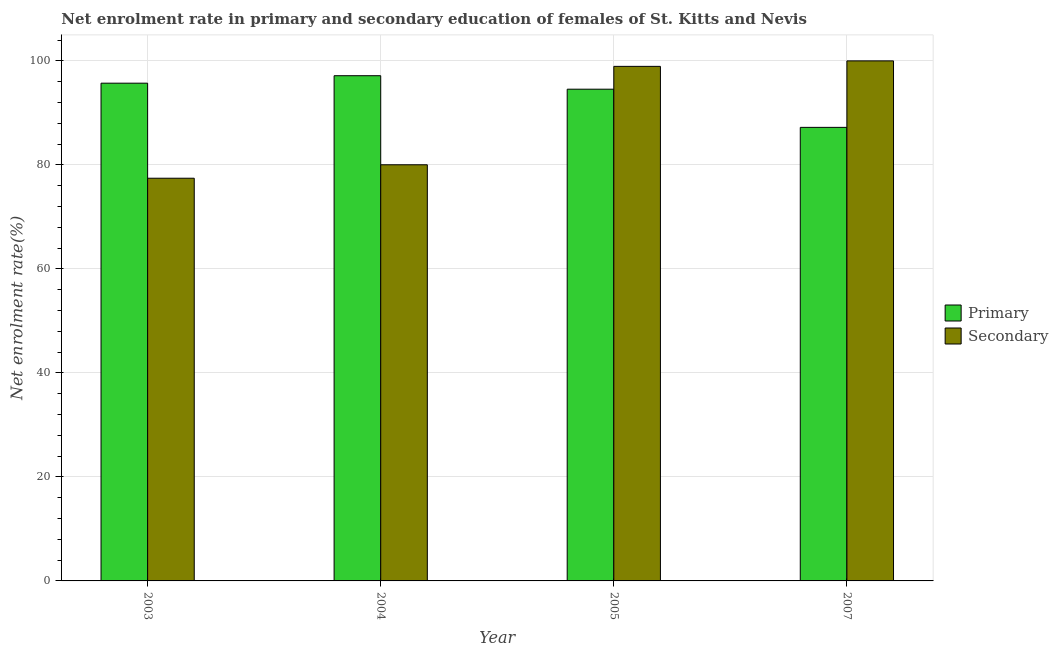How many different coloured bars are there?
Your response must be concise. 2. Are the number of bars per tick equal to the number of legend labels?
Offer a very short reply. Yes. Are the number of bars on each tick of the X-axis equal?
Provide a succinct answer. Yes. What is the enrollment rate in primary education in 2003?
Ensure brevity in your answer.  95.71. Across all years, what is the maximum enrollment rate in primary education?
Offer a very short reply. 97.15. Across all years, what is the minimum enrollment rate in primary education?
Provide a succinct answer. 87.21. What is the total enrollment rate in primary education in the graph?
Your response must be concise. 374.63. What is the difference between the enrollment rate in secondary education in 2004 and that in 2007?
Provide a short and direct response. -19.98. What is the difference between the enrollment rate in primary education in 2005 and the enrollment rate in secondary education in 2007?
Ensure brevity in your answer.  7.34. What is the average enrollment rate in primary education per year?
Provide a succinct answer. 93.66. In the year 2003, what is the difference between the enrollment rate in secondary education and enrollment rate in primary education?
Make the answer very short. 0. In how many years, is the enrollment rate in primary education greater than 8 %?
Provide a succinct answer. 4. What is the ratio of the enrollment rate in primary education in 2004 to that in 2007?
Make the answer very short. 1.11. What is the difference between the highest and the second highest enrollment rate in secondary education?
Make the answer very short. 1.06. What is the difference between the highest and the lowest enrollment rate in secondary education?
Make the answer very short. 22.57. In how many years, is the enrollment rate in secondary education greater than the average enrollment rate in secondary education taken over all years?
Make the answer very short. 2. What does the 2nd bar from the left in 2005 represents?
Your answer should be very brief. Secondary. What does the 1st bar from the right in 2007 represents?
Keep it short and to the point. Secondary. How many bars are there?
Your response must be concise. 8. Are all the bars in the graph horizontal?
Offer a very short reply. No. How many years are there in the graph?
Ensure brevity in your answer.  4. What is the difference between two consecutive major ticks on the Y-axis?
Ensure brevity in your answer.  20. Does the graph contain any zero values?
Your answer should be very brief. No. Does the graph contain grids?
Ensure brevity in your answer.  Yes. Where does the legend appear in the graph?
Provide a succinct answer. Center right. How many legend labels are there?
Your response must be concise. 2. How are the legend labels stacked?
Keep it short and to the point. Vertical. What is the title of the graph?
Your response must be concise. Net enrolment rate in primary and secondary education of females of St. Kitts and Nevis. What is the label or title of the Y-axis?
Your response must be concise. Net enrolment rate(%). What is the Net enrolment rate(%) of Primary in 2003?
Offer a terse response. 95.71. What is the Net enrolment rate(%) in Secondary in 2003?
Keep it short and to the point. 77.43. What is the Net enrolment rate(%) in Primary in 2004?
Ensure brevity in your answer.  97.15. What is the Net enrolment rate(%) of Secondary in 2004?
Give a very brief answer. 80.02. What is the Net enrolment rate(%) of Primary in 2005?
Provide a short and direct response. 94.55. What is the Net enrolment rate(%) of Secondary in 2005?
Give a very brief answer. 98.94. What is the Net enrolment rate(%) of Primary in 2007?
Offer a very short reply. 87.21. What is the Net enrolment rate(%) of Secondary in 2007?
Offer a very short reply. 100. Across all years, what is the maximum Net enrolment rate(%) in Primary?
Offer a very short reply. 97.15. Across all years, what is the maximum Net enrolment rate(%) of Secondary?
Provide a short and direct response. 100. Across all years, what is the minimum Net enrolment rate(%) of Primary?
Offer a very short reply. 87.21. Across all years, what is the minimum Net enrolment rate(%) of Secondary?
Your response must be concise. 77.43. What is the total Net enrolment rate(%) of Primary in the graph?
Ensure brevity in your answer.  374.63. What is the total Net enrolment rate(%) of Secondary in the graph?
Keep it short and to the point. 356.4. What is the difference between the Net enrolment rate(%) of Primary in 2003 and that in 2004?
Provide a short and direct response. -1.44. What is the difference between the Net enrolment rate(%) in Secondary in 2003 and that in 2004?
Provide a short and direct response. -2.59. What is the difference between the Net enrolment rate(%) of Primary in 2003 and that in 2005?
Your response must be concise. 1.16. What is the difference between the Net enrolment rate(%) in Secondary in 2003 and that in 2005?
Your response must be concise. -21.51. What is the difference between the Net enrolment rate(%) of Primary in 2003 and that in 2007?
Keep it short and to the point. 8.5. What is the difference between the Net enrolment rate(%) in Secondary in 2003 and that in 2007?
Provide a short and direct response. -22.57. What is the difference between the Net enrolment rate(%) in Primary in 2004 and that in 2005?
Ensure brevity in your answer.  2.59. What is the difference between the Net enrolment rate(%) of Secondary in 2004 and that in 2005?
Give a very brief answer. -18.92. What is the difference between the Net enrolment rate(%) in Primary in 2004 and that in 2007?
Your answer should be very brief. 9.93. What is the difference between the Net enrolment rate(%) in Secondary in 2004 and that in 2007?
Give a very brief answer. -19.98. What is the difference between the Net enrolment rate(%) in Primary in 2005 and that in 2007?
Give a very brief answer. 7.34. What is the difference between the Net enrolment rate(%) of Secondary in 2005 and that in 2007?
Offer a very short reply. -1.06. What is the difference between the Net enrolment rate(%) of Primary in 2003 and the Net enrolment rate(%) of Secondary in 2004?
Your answer should be very brief. 15.69. What is the difference between the Net enrolment rate(%) of Primary in 2003 and the Net enrolment rate(%) of Secondary in 2005?
Your response must be concise. -3.23. What is the difference between the Net enrolment rate(%) in Primary in 2003 and the Net enrolment rate(%) in Secondary in 2007?
Your answer should be compact. -4.29. What is the difference between the Net enrolment rate(%) in Primary in 2004 and the Net enrolment rate(%) in Secondary in 2005?
Make the answer very short. -1.8. What is the difference between the Net enrolment rate(%) of Primary in 2004 and the Net enrolment rate(%) of Secondary in 2007?
Offer a terse response. -2.85. What is the difference between the Net enrolment rate(%) of Primary in 2005 and the Net enrolment rate(%) of Secondary in 2007?
Provide a succinct answer. -5.45. What is the average Net enrolment rate(%) of Primary per year?
Offer a very short reply. 93.66. What is the average Net enrolment rate(%) of Secondary per year?
Ensure brevity in your answer.  89.1. In the year 2003, what is the difference between the Net enrolment rate(%) in Primary and Net enrolment rate(%) in Secondary?
Keep it short and to the point. 18.28. In the year 2004, what is the difference between the Net enrolment rate(%) of Primary and Net enrolment rate(%) of Secondary?
Ensure brevity in your answer.  17.13. In the year 2005, what is the difference between the Net enrolment rate(%) in Primary and Net enrolment rate(%) in Secondary?
Give a very brief answer. -4.39. In the year 2007, what is the difference between the Net enrolment rate(%) in Primary and Net enrolment rate(%) in Secondary?
Offer a terse response. -12.79. What is the ratio of the Net enrolment rate(%) in Primary in 2003 to that in 2004?
Offer a terse response. 0.99. What is the ratio of the Net enrolment rate(%) of Secondary in 2003 to that in 2004?
Ensure brevity in your answer.  0.97. What is the ratio of the Net enrolment rate(%) of Primary in 2003 to that in 2005?
Your response must be concise. 1.01. What is the ratio of the Net enrolment rate(%) in Secondary in 2003 to that in 2005?
Your answer should be very brief. 0.78. What is the ratio of the Net enrolment rate(%) in Primary in 2003 to that in 2007?
Give a very brief answer. 1.1. What is the ratio of the Net enrolment rate(%) in Secondary in 2003 to that in 2007?
Provide a succinct answer. 0.77. What is the ratio of the Net enrolment rate(%) of Primary in 2004 to that in 2005?
Offer a terse response. 1.03. What is the ratio of the Net enrolment rate(%) of Secondary in 2004 to that in 2005?
Offer a very short reply. 0.81. What is the ratio of the Net enrolment rate(%) of Primary in 2004 to that in 2007?
Offer a very short reply. 1.11. What is the ratio of the Net enrolment rate(%) in Secondary in 2004 to that in 2007?
Your answer should be very brief. 0.8. What is the ratio of the Net enrolment rate(%) of Primary in 2005 to that in 2007?
Offer a terse response. 1.08. What is the ratio of the Net enrolment rate(%) in Secondary in 2005 to that in 2007?
Your answer should be very brief. 0.99. What is the difference between the highest and the second highest Net enrolment rate(%) in Primary?
Offer a terse response. 1.44. What is the difference between the highest and the second highest Net enrolment rate(%) in Secondary?
Give a very brief answer. 1.06. What is the difference between the highest and the lowest Net enrolment rate(%) of Primary?
Ensure brevity in your answer.  9.93. What is the difference between the highest and the lowest Net enrolment rate(%) of Secondary?
Ensure brevity in your answer.  22.57. 